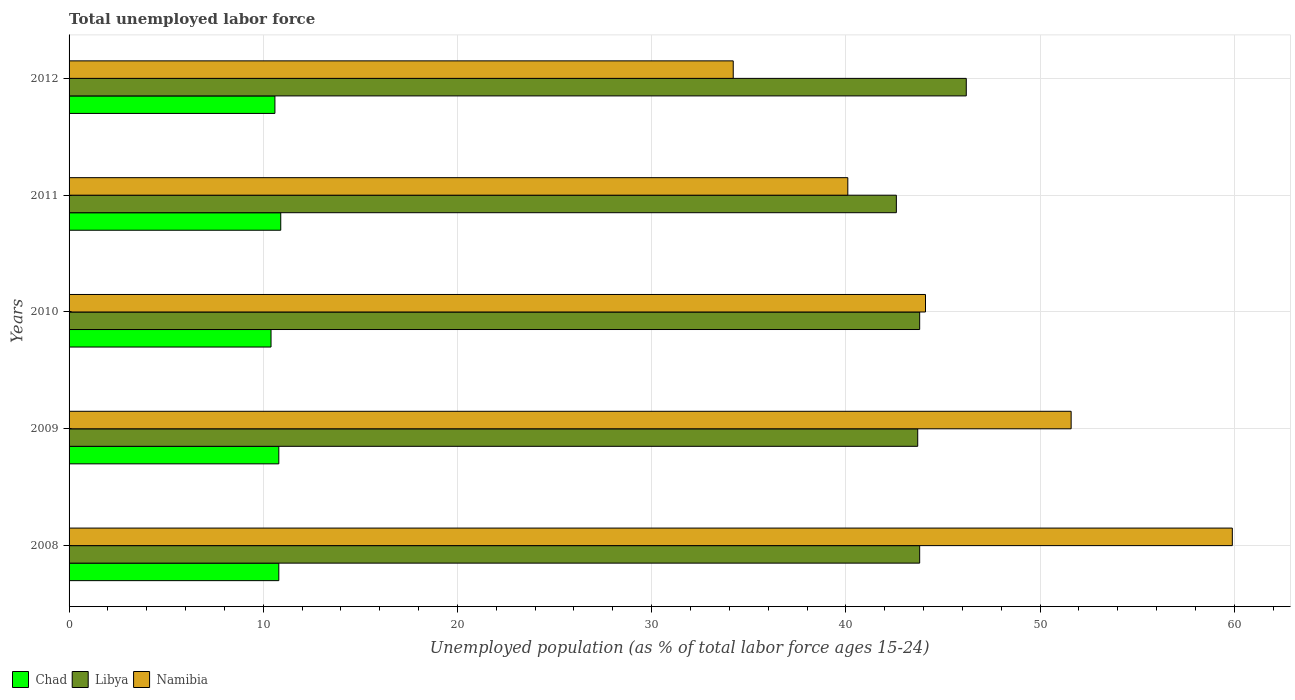How many different coloured bars are there?
Your answer should be compact. 3. How many groups of bars are there?
Your response must be concise. 5. What is the label of the 1st group of bars from the top?
Your answer should be compact. 2012. What is the percentage of unemployed population in in Libya in 2011?
Make the answer very short. 42.6. Across all years, what is the maximum percentage of unemployed population in in Libya?
Provide a succinct answer. 46.2. Across all years, what is the minimum percentage of unemployed population in in Namibia?
Make the answer very short. 34.2. What is the total percentage of unemployed population in in Chad in the graph?
Offer a very short reply. 53.5. What is the difference between the percentage of unemployed population in in Libya in 2009 and that in 2010?
Provide a short and direct response. -0.1. What is the difference between the percentage of unemployed population in in Chad in 2010 and the percentage of unemployed population in in Libya in 2009?
Make the answer very short. -33.3. What is the average percentage of unemployed population in in Namibia per year?
Offer a very short reply. 45.98. In the year 2010, what is the difference between the percentage of unemployed population in in Namibia and percentage of unemployed population in in Chad?
Your answer should be very brief. 33.7. What is the ratio of the percentage of unemployed population in in Libya in 2009 to that in 2011?
Ensure brevity in your answer.  1.03. Is the percentage of unemployed population in in Namibia in 2009 less than that in 2010?
Give a very brief answer. No. What is the difference between the highest and the second highest percentage of unemployed population in in Namibia?
Provide a succinct answer. 8.3. What is the difference between the highest and the lowest percentage of unemployed population in in Chad?
Provide a succinct answer. 0.5. Is the sum of the percentage of unemployed population in in Namibia in 2008 and 2009 greater than the maximum percentage of unemployed population in in Chad across all years?
Provide a short and direct response. Yes. What does the 1st bar from the top in 2009 represents?
Offer a terse response. Namibia. What does the 2nd bar from the bottom in 2008 represents?
Give a very brief answer. Libya. Is it the case that in every year, the sum of the percentage of unemployed population in in Chad and percentage of unemployed population in in Libya is greater than the percentage of unemployed population in in Namibia?
Make the answer very short. No. How many years are there in the graph?
Provide a succinct answer. 5. How are the legend labels stacked?
Provide a succinct answer. Horizontal. What is the title of the graph?
Give a very brief answer. Total unemployed labor force. What is the label or title of the X-axis?
Provide a succinct answer. Unemployed population (as % of total labor force ages 15-24). What is the Unemployed population (as % of total labor force ages 15-24) of Chad in 2008?
Offer a terse response. 10.8. What is the Unemployed population (as % of total labor force ages 15-24) in Libya in 2008?
Offer a terse response. 43.8. What is the Unemployed population (as % of total labor force ages 15-24) in Namibia in 2008?
Provide a succinct answer. 59.9. What is the Unemployed population (as % of total labor force ages 15-24) of Chad in 2009?
Make the answer very short. 10.8. What is the Unemployed population (as % of total labor force ages 15-24) of Libya in 2009?
Ensure brevity in your answer.  43.7. What is the Unemployed population (as % of total labor force ages 15-24) in Namibia in 2009?
Offer a very short reply. 51.6. What is the Unemployed population (as % of total labor force ages 15-24) of Chad in 2010?
Offer a very short reply. 10.4. What is the Unemployed population (as % of total labor force ages 15-24) in Libya in 2010?
Provide a succinct answer. 43.8. What is the Unemployed population (as % of total labor force ages 15-24) in Namibia in 2010?
Make the answer very short. 44.1. What is the Unemployed population (as % of total labor force ages 15-24) of Chad in 2011?
Give a very brief answer. 10.9. What is the Unemployed population (as % of total labor force ages 15-24) of Libya in 2011?
Give a very brief answer. 42.6. What is the Unemployed population (as % of total labor force ages 15-24) in Namibia in 2011?
Ensure brevity in your answer.  40.1. What is the Unemployed population (as % of total labor force ages 15-24) in Chad in 2012?
Make the answer very short. 10.6. What is the Unemployed population (as % of total labor force ages 15-24) of Libya in 2012?
Provide a short and direct response. 46.2. What is the Unemployed population (as % of total labor force ages 15-24) of Namibia in 2012?
Provide a short and direct response. 34.2. Across all years, what is the maximum Unemployed population (as % of total labor force ages 15-24) of Chad?
Provide a short and direct response. 10.9. Across all years, what is the maximum Unemployed population (as % of total labor force ages 15-24) of Libya?
Your answer should be compact. 46.2. Across all years, what is the maximum Unemployed population (as % of total labor force ages 15-24) of Namibia?
Offer a very short reply. 59.9. Across all years, what is the minimum Unemployed population (as % of total labor force ages 15-24) of Chad?
Make the answer very short. 10.4. Across all years, what is the minimum Unemployed population (as % of total labor force ages 15-24) in Libya?
Offer a very short reply. 42.6. Across all years, what is the minimum Unemployed population (as % of total labor force ages 15-24) of Namibia?
Offer a terse response. 34.2. What is the total Unemployed population (as % of total labor force ages 15-24) of Chad in the graph?
Give a very brief answer. 53.5. What is the total Unemployed population (as % of total labor force ages 15-24) in Libya in the graph?
Give a very brief answer. 220.1. What is the total Unemployed population (as % of total labor force ages 15-24) of Namibia in the graph?
Your answer should be compact. 229.9. What is the difference between the Unemployed population (as % of total labor force ages 15-24) in Chad in 2008 and that in 2010?
Your response must be concise. 0.4. What is the difference between the Unemployed population (as % of total labor force ages 15-24) in Libya in 2008 and that in 2010?
Provide a succinct answer. 0. What is the difference between the Unemployed population (as % of total labor force ages 15-24) of Namibia in 2008 and that in 2011?
Keep it short and to the point. 19.8. What is the difference between the Unemployed population (as % of total labor force ages 15-24) of Chad in 2008 and that in 2012?
Offer a very short reply. 0.2. What is the difference between the Unemployed population (as % of total labor force ages 15-24) of Namibia in 2008 and that in 2012?
Your answer should be very brief. 25.7. What is the difference between the Unemployed population (as % of total labor force ages 15-24) in Libya in 2009 and that in 2010?
Provide a succinct answer. -0.1. What is the difference between the Unemployed population (as % of total labor force ages 15-24) of Libya in 2009 and that in 2011?
Provide a short and direct response. 1.1. What is the difference between the Unemployed population (as % of total labor force ages 15-24) of Chad in 2009 and that in 2012?
Give a very brief answer. 0.2. What is the difference between the Unemployed population (as % of total labor force ages 15-24) in Chad in 2010 and that in 2011?
Provide a succinct answer. -0.5. What is the difference between the Unemployed population (as % of total labor force ages 15-24) in Libya in 2010 and that in 2012?
Offer a terse response. -2.4. What is the difference between the Unemployed population (as % of total labor force ages 15-24) of Namibia in 2010 and that in 2012?
Offer a terse response. 9.9. What is the difference between the Unemployed population (as % of total labor force ages 15-24) in Chad in 2011 and that in 2012?
Give a very brief answer. 0.3. What is the difference between the Unemployed population (as % of total labor force ages 15-24) in Libya in 2011 and that in 2012?
Provide a succinct answer. -3.6. What is the difference between the Unemployed population (as % of total labor force ages 15-24) in Chad in 2008 and the Unemployed population (as % of total labor force ages 15-24) in Libya in 2009?
Provide a succinct answer. -32.9. What is the difference between the Unemployed population (as % of total labor force ages 15-24) of Chad in 2008 and the Unemployed population (as % of total labor force ages 15-24) of Namibia in 2009?
Offer a very short reply. -40.8. What is the difference between the Unemployed population (as % of total labor force ages 15-24) in Chad in 2008 and the Unemployed population (as % of total labor force ages 15-24) in Libya in 2010?
Give a very brief answer. -33. What is the difference between the Unemployed population (as % of total labor force ages 15-24) in Chad in 2008 and the Unemployed population (as % of total labor force ages 15-24) in Namibia in 2010?
Your response must be concise. -33.3. What is the difference between the Unemployed population (as % of total labor force ages 15-24) in Libya in 2008 and the Unemployed population (as % of total labor force ages 15-24) in Namibia in 2010?
Ensure brevity in your answer.  -0.3. What is the difference between the Unemployed population (as % of total labor force ages 15-24) of Chad in 2008 and the Unemployed population (as % of total labor force ages 15-24) of Libya in 2011?
Ensure brevity in your answer.  -31.8. What is the difference between the Unemployed population (as % of total labor force ages 15-24) of Chad in 2008 and the Unemployed population (as % of total labor force ages 15-24) of Namibia in 2011?
Provide a short and direct response. -29.3. What is the difference between the Unemployed population (as % of total labor force ages 15-24) in Libya in 2008 and the Unemployed population (as % of total labor force ages 15-24) in Namibia in 2011?
Your answer should be compact. 3.7. What is the difference between the Unemployed population (as % of total labor force ages 15-24) in Chad in 2008 and the Unemployed population (as % of total labor force ages 15-24) in Libya in 2012?
Your response must be concise. -35.4. What is the difference between the Unemployed population (as % of total labor force ages 15-24) of Chad in 2008 and the Unemployed population (as % of total labor force ages 15-24) of Namibia in 2012?
Ensure brevity in your answer.  -23.4. What is the difference between the Unemployed population (as % of total labor force ages 15-24) in Libya in 2008 and the Unemployed population (as % of total labor force ages 15-24) in Namibia in 2012?
Your answer should be compact. 9.6. What is the difference between the Unemployed population (as % of total labor force ages 15-24) in Chad in 2009 and the Unemployed population (as % of total labor force ages 15-24) in Libya in 2010?
Make the answer very short. -33. What is the difference between the Unemployed population (as % of total labor force ages 15-24) in Chad in 2009 and the Unemployed population (as % of total labor force ages 15-24) in Namibia in 2010?
Make the answer very short. -33.3. What is the difference between the Unemployed population (as % of total labor force ages 15-24) of Libya in 2009 and the Unemployed population (as % of total labor force ages 15-24) of Namibia in 2010?
Give a very brief answer. -0.4. What is the difference between the Unemployed population (as % of total labor force ages 15-24) of Chad in 2009 and the Unemployed population (as % of total labor force ages 15-24) of Libya in 2011?
Keep it short and to the point. -31.8. What is the difference between the Unemployed population (as % of total labor force ages 15-24) of Chad in 2009 and the Unemployed population (as % of total labor force ages 15-24) of Namibia in 2011?
Offer a very short reply. -29.3. What is the difference between the Unemployed population (as % of total labor force ages 15-24) in Libya in 2009 and the Unemployed population (as % of total labor force ages 15-24) in Namibia in 2011?
Offer a terse response. 3.6. What is the difference between the Unemployed population (as % of total labor force ages 15-24) in Chad in 2009 and the Unemployed population (as % of total labor force ages 15-24) in Libya in 2012?
Keep it short and to the point. -35.4. What is the difference between the Unemployed population (as % of total labor force ages 15-24) of Chad in 2009 and the Unemployed population (as % of total labor force ages 15-24) of Namibia in 2012?
Provide a short and direct response. -23.4. What is the difference between the Unemployed population (as % of total labor force ages 15-24) in Chad in 2010 and the Unemployed population (as % of total labor force ages 15-24) in Libya in 2011?
Give a very brief answer. -32.2. What is the difference between the Unemployed population (as % of total labor force ages 15-24) of Chad in 2010 and the Unemployed population (as % of total labor force ages 15-24) of Namibia in 2011?
Offer a terse response. -29.7. What is the difference between the Unemployed population (as % of total labor force ages 15-24) of Libya in 2010 and the Unemployed population (as % of total labor force ages 15-24) of Namibia in 2011?
Offer a very short reply. 3.7. What is the difference between the Unemployed population (as % of total labor force ages 15-24) in Chad in 2010 and the Unemployed population (as % of total labor force ages 15-24) in Libya in 2012?
Ensure brevity in your answer.  -35.8. What is the difference between the Unemployed population (as % of total labor force ages 15-24) of Chad in 2010 and the Unemployed population (as % of total labor force ages 15-24) of Namibia in 2012?
Ensure brevity in your answer.  -23.8. What is the difference between the Unemployed population (as % of total labor force ages 15-24) of Libya in 2010 and the Unemployed population (as % of total labor force ages 15-24) of Namibia in 2012?
Provide a succinct answer. 9.6. What is the difference between the Unemployed population (as % of total labor force ages 15-24) of Chad in 2011 and the Unemployed population (as % of total labor force ages 15-24) of Libya in 2012?
Keep it short and to the point. -35.3. What is the difference between the Unemployed population (as % of total labor force ages 15-24) of Chad in 2011 and the Unemployed population (as % of total labor force ages 15-24) of Namibia in 2012?
Your response must be concise. -23.3. What is the average Unemployed population (as % of total labor force ages 15-24) in Libya per year?
Ensure brevity in your answer.  44.02. What is the average Unemployed population (as % of total labor force ages 15-24) of Namibia per year?
Keep it short and to the point. 45.98. In the year 2008, what is the difference between the Unemployed population (as % of total labor force ages 15-24) in Chad and Unemployed population (as % of total labor force ages 15-24) in Libya?
Your answer should be compact. -33. In the year 2008, what is the difference between the Unemployed population (as % of total labor force ages 15-24) in Chad and Unemployed population (as % of total labor force ages 15-24) in Namibia?
Keep it short and to the point. -49.1. In the year 2008, what is the difference between the Unemployed population (as % of total labor force ages 15-24) in Libya and Unemployed population (as % of total labor force ages 15-24) in Namibia?
Provide a short and direct response. -16.1. In the year 2009, what is the difference between the Unemployed population (as % of total labor force ages 15-24) of Chad and Unemployed population (as % of total labor force ages 15-24) of Libya?
Your answer should be very brief. -32.9. In the year 2009, what is the difference between the Unemployed population (as % of total labor force ages 15-24) of Chad and Unemployed population (as % of total labor force ages 15-24) of Namibia?
Keep it short and to the point. -40.8. In the year 2009, what is the difference between the Unemployed population (as % of total labor force ages 15-24) of Libya and Unemployed population (as % of total labor force ages 15-24) of Namibia?
Ensure brevity in your answer.  -7.9. In the year 2010, what is the difference between the Unemployed population (as % of total labor force ages 15-24) in Chad and Unemployed population (as % of total labor force ages 15-24) in Libya?
Give a very brief answer. -33.4. In the year 2010, what is the difference between the Unemployed population (as % of total labor force ages 15-24) of Chad and Unemployed population (as % of total labor force ages 15-24) of Namibia?
Your answer should be compact. -33.7. In the year 2011, what is the difference between the Unemployed population (as % of total labor force ages 15-24) in Chad and Unemployed population (as % of total labor force ages 15-24) in Libya?
Make the answer very short. -31.7. In the year 2011, what is the difference between the Unemployed population (as % of total labor force ages 15-24) of Chad and Unemployed population (as % of total labor force ages 15-24) of Namibia?
Give a very brief answer. -29.2. In the year 2011, what is the difference between the Unemployed population (as % of total labor force ages 15-24) in Libya and Unemployed population (as % of total labor force ages 15-24) in Namibia?
Make the answer very short. 2.5. In the year 2012, what is the difference between the Unemployed population (as % of total labor force ages 15-24) of Chad and Unemployed population (as % of total labor force ages 15-24) of Libya?
Ensure brevity in your answer.  -35.6. In the year 2012, what is the difference between the Unemployed population (as % of total labor force ages 15-24) in Chad and Unemployed population (as % of total labor force ages 15-24) in Namibia?
Give a very brief answer. -23.6. In the year 2012, what is the difference between the Unemployed population (as % of total labor force ages 15-24) in Libya and Unemployed population (as % of total labor force ages 15-24) in Namibia?
Your response must be concise. 12. What is the ratio of the Unemployed population (as % of total labor force ages 15-24) in Namibia in 2008 to that in 2009?
Provide a short and direct response. 1.16. What is the ratio of the Unemployed population (as % of total labor force ages 15-24) in Chad in 2008 to that in 2010?
Your answer should be compact. 1.04. What is the ratio of the Unemployed population (as % of total labor force ages 15-24) in Namibia in 2008 to that in 2010?
Provide a short and direct response. 1.36. What is the ratio of the Unemployed population (as % of total labor force ages 15-24) of Chad in 2008 to that in 2011?
Keep it short and to the point. 0.99. What is the ratio of the Unemployed population (as % of total labor force ages 15-24) in Libya in 2008 to that in 2011?
Provide a short and direct response. 1.03. What is the ratio of the Unemployed population (as % of total labor force ages 15-24) in Namibia in 2008 to that in 2011?
Offer a terse response. 1.49. What is the ratio of the Unemployed population (as % of total labor force ages 15-24) of Chad in 2008 to that in 2012?
Your response must be concise. 1.02. What is the ratio of the Unemployed population (as % of total labor force ages 15-24) of Libya in 2008 to that in 2012?
Offer a very short reply. 0.95. What is the ratio of the Unemployed population (as % of total labor force ages 15-24) in Namibia in 2008 to that in 2012?
Provide a short and direct response. 1.75. What is the ratio of the Unemployed population (as % of total labor force ages 15-24) of Libya in 2009 to that in 2010?
Keep it short and to the point. 1. What is the ratio of the Unemployed population (as % of total labor force ages 15-24) in Namibia in 2009 to that in 2010?
Offer a terse response. 1.17. What is the ratio of the Unemployed population (as % of total labor force ages 15-24) in Libya in 2009 to that in 2011?
Provide a short and direct response. 1.03. What is the ratio of the Unemployed population (as % of total labor force ages 15-24) of Namibia in 2009 to that in 2011?
Provide a succinct answer. 1.29. What is the ratio of the Unemployed population (as % of total labor force ages 15-24) in Chad in 2009 to that in 2012?
Your answer should be very brief. 1.02. What is the ratio of the Unemployed population (as % of total labor force ages 15-24) in Libya in 2009 to that in 2012?
Your response must be concise. 0.95. What is the ratio of the Unemployed population (as % of total labor force ages 15-24) in Namibia in 2009 to that in 2012?
Provide a short and direct response. 1.51. What is the ratio of the Unemployed population (as % of total labor force ages 15-24) in Chad in 2010 to that in 2011?
Keep it short and to the point. 0.95. What is the ratio of the Unemployed population (as % of total labor force ages 15-24) in Libya in 2010 to that in 2011?
Ensure brevity in your answer.  1.03. What is the ratio of the Unemployed population (as % of total labor force ages 15-24) of Namibia in 2010 to that in 2011?
Give a very brief answer. 1.1. What is the ratio of the Unemployed population (as % of total labor force ages 15-24) in Chad in 2010 to that in 2012?
Provide a short and direct response. 0.98. What is the ratio of the Unemployed population (as % of total labor force ages 15-24) in Libya in 2010 to that in 2012?
Give a very brief answer. 0.95. What is the ratio of the Unemployed population (as % of total labor force ages 15-24) of Namibia in 2010 to that in 2012?
Provide a succinct answer. 1.29. What is the ratio of the Unemployed population (as % of total labor force ages 15-24) in Chad in 2011 to that in 2012?
Your answer should be very brief. 1.03. What is the ratio of the Unemployed population (as % of total labor force ages 15-24) of Libya in 2011 to that in 2012?
Your response must be concise. 0.92. What is the ratio of the Unemployed population (as % of total labor force ages 15-24) of Namibia in 2011 to that in 2012?
Your answer should be compact. 1.17. What is the difference between the highest and the second highest Unemployed population (as % of total labor force ages 15-24) of Chad?
Provide a succinct answer. 0.1. What is the difference between the highest and the second highest Unemployed population (as % of total labor force ages 15-24) of Namibia?
Make the answer very short. 8.3. What is the difference between the highest and the lowest Unemployed population (as % of total labor force ages 15-24) of Chad?
Offer a very short reply. 0.5. What is the difference between the highest and the lowest Unemployed population (as % of total labor force ages 15-24) of Namibia?
Provide a short and direct response. 25.7. 